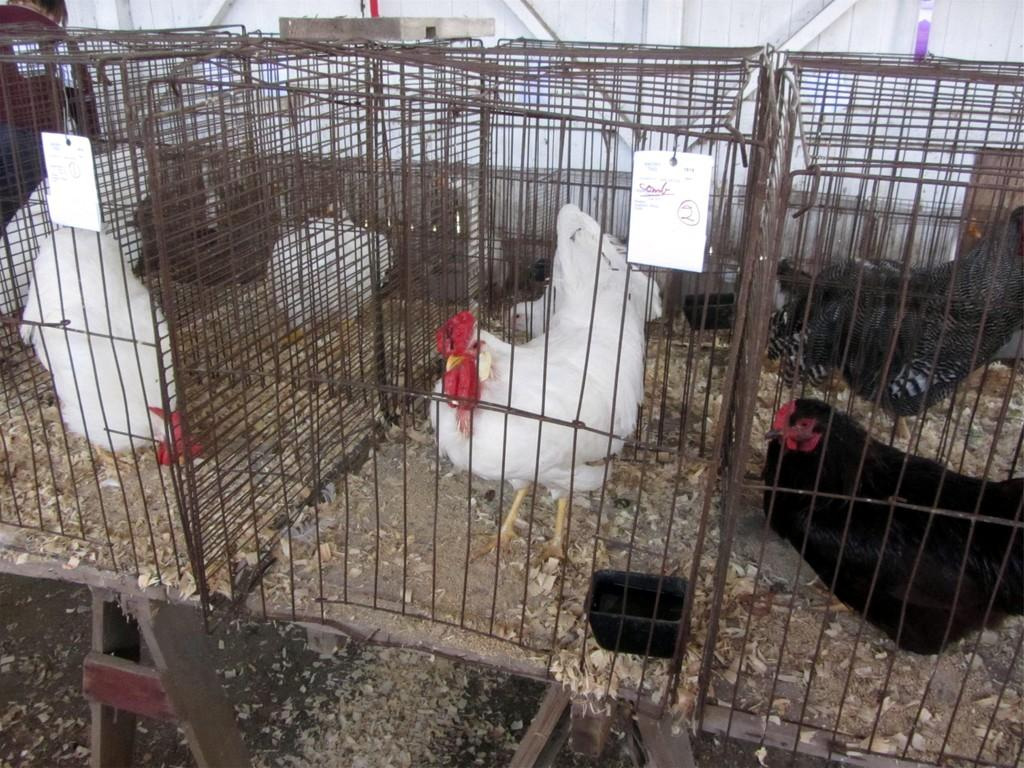What type of animals are present in the image? There are hens in the image. Where are the hens located? The hens are in a cage. What books are the hens reading in the image? There are no books present in the image; it features hens in a cage. 